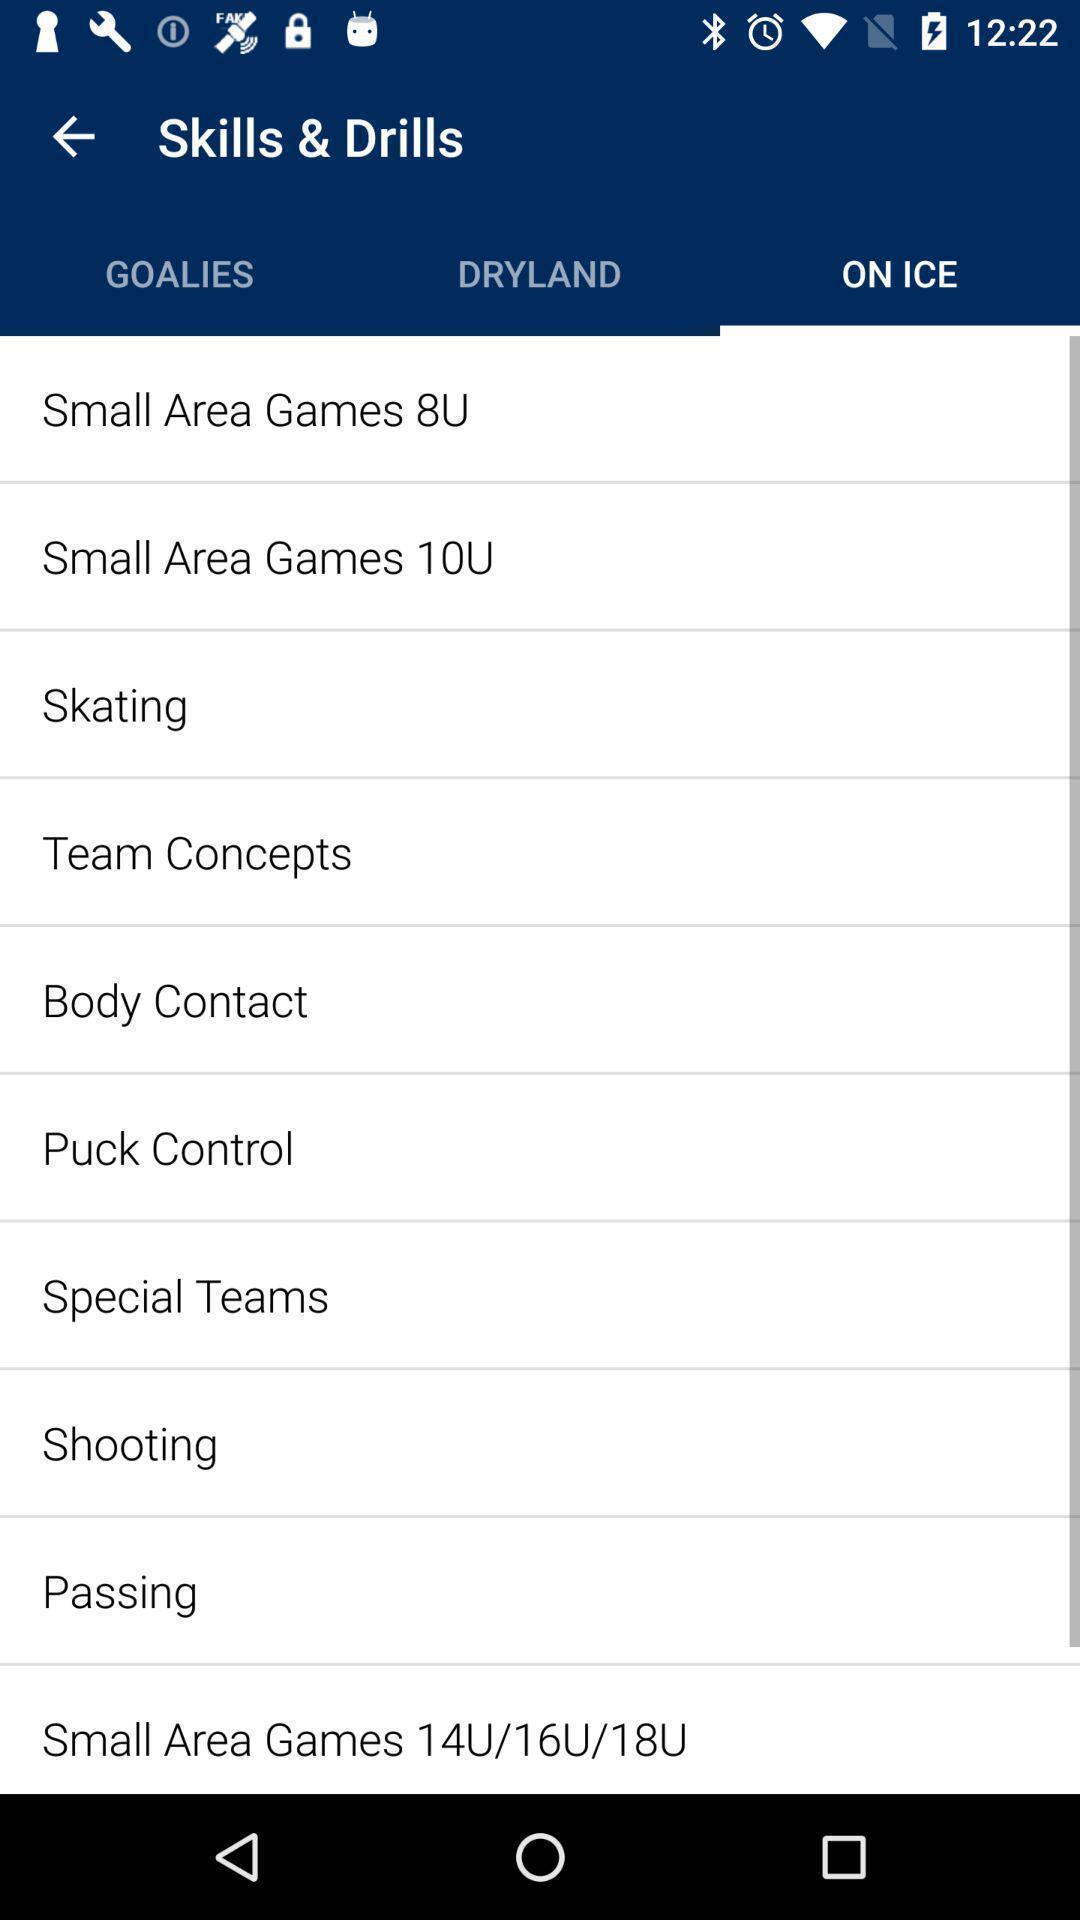Explain what's happening in this screen capture. Various kinds of gaming skills in the application. 